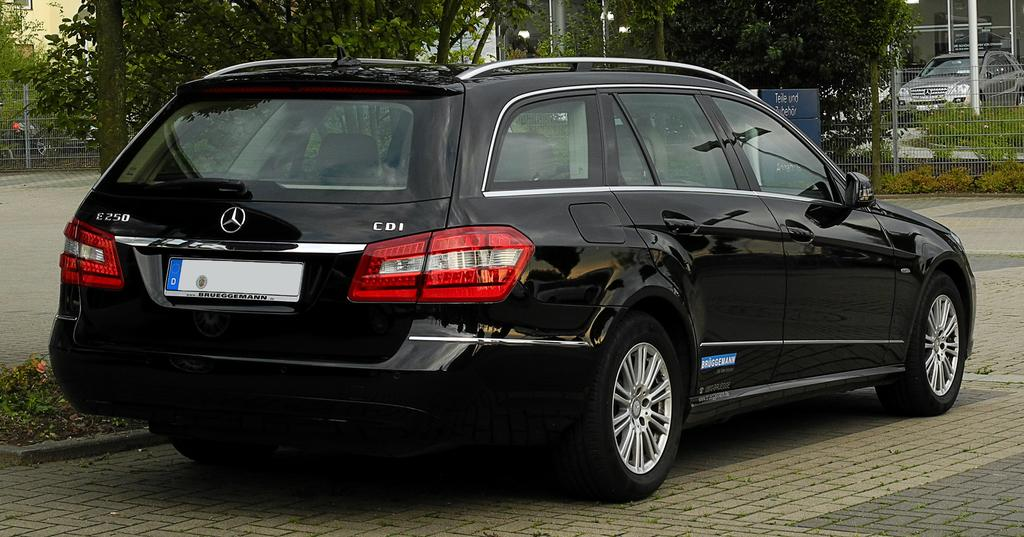What is the main subject in the center of the image? There is a car in the center of the image. What color is the car? The car is black. What can be seen in the background of the image? There are trees, a fence, and poles in the background of the image. Are there any other cars visible in the image? Yes, there is another car in the background of the image. What type of experience does the driver of the car have? The image does not provide any information about the driver or their experience, as it only shows a black car and background elements. 